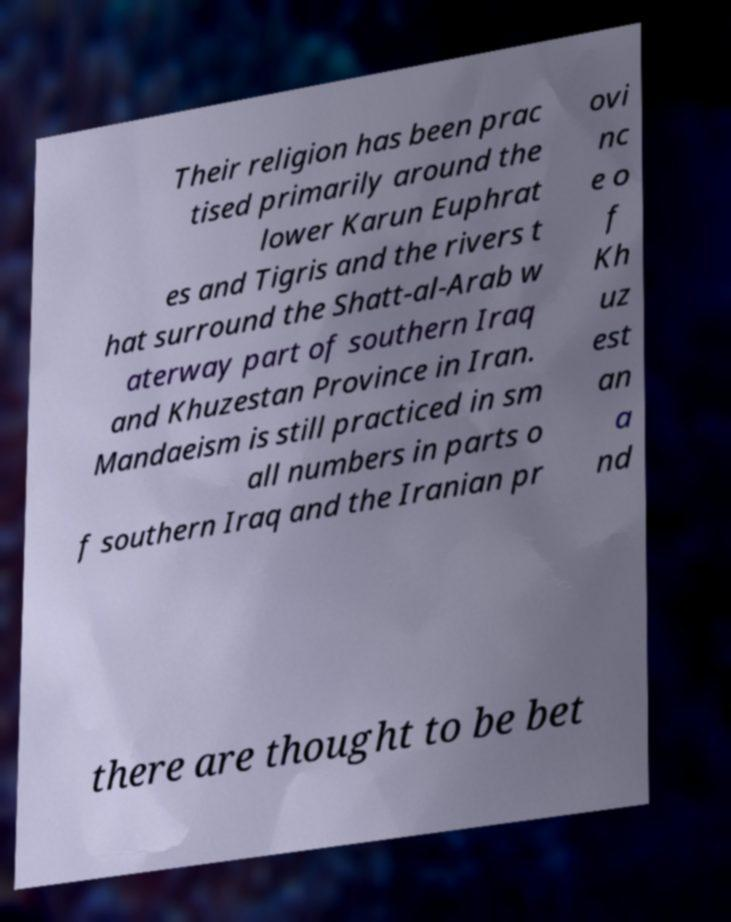Please read and relay the text visible in this image. What does it say? Their religion has been prac tised primarily around the lower Karun Euphrat es and Tigris and the rivers t hat surround the Shatt-al-Arab w aterway part of southern Iraq and Khuzestan Province in Iran. Mandaeism is still practiced in sm all numbers in parts o f southern Iraq and the Iranian pr ovi nc e o f Kh uz est an a nd there are thought to be bet 